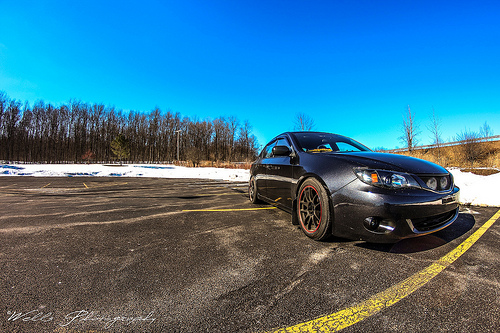<image>
Can you confirm if the car is next to the sky? No. The car is not positioned next to the sky. They are located in different areas of the scene. Is there a car next to the trees? No. The car is not positioned next to the trees. They are located in different areas of the scene. Is there a sky behind the car? Yes. From this viewpoint, the sky is positioned behind the car, with the car partially or fully occluding the sky. 